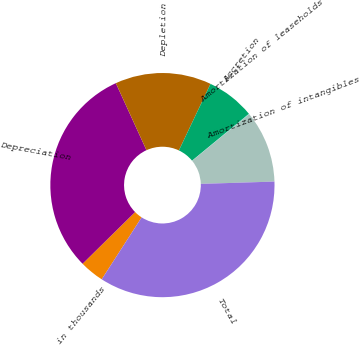Convert chart to OTSL. <chart><loc_0><loc_0><loc_500><loc_500><pie_chart><fcel>in thousands<fcel>Depreciation<fcel>Depletion<fcel>Accretion<fcel>Amortization of leaseholds<fcel>Amortization of intangibles<fcel>Total<nl><fcel>3.51%<fcel>30.56%<fcel>13.88%<fcel>6.97%<fcel>0.05%<fcel>10.42%<fcel>34.61%<nl></chart> 